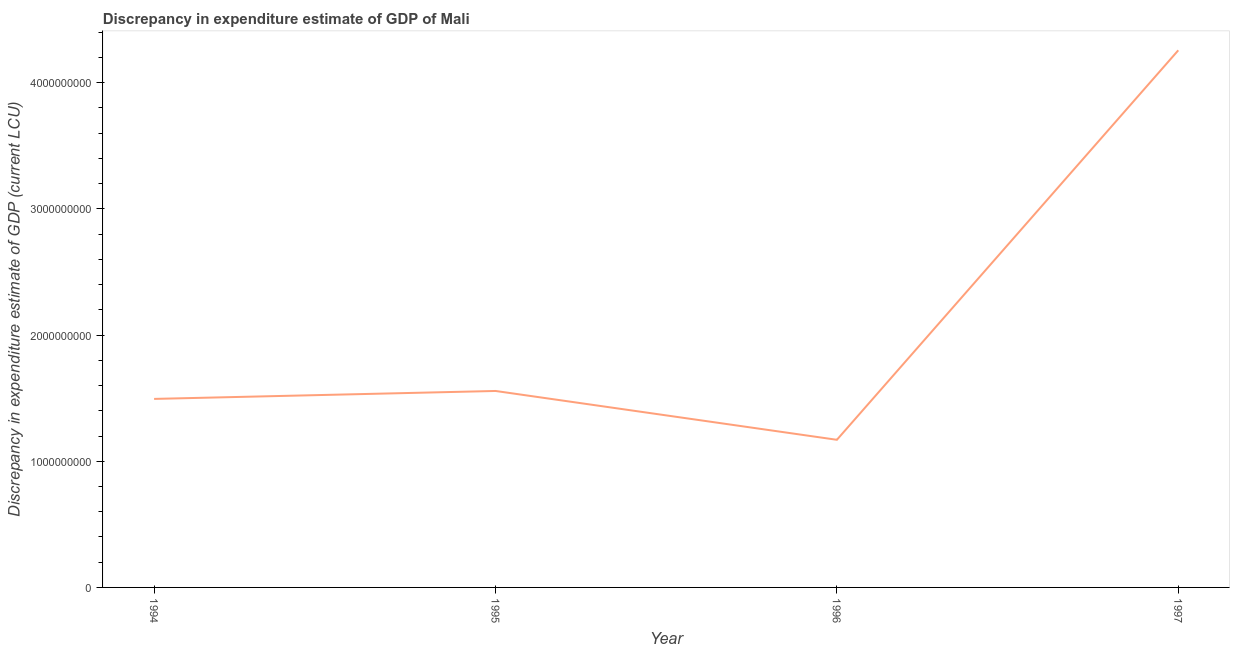What is the discrepancy in expenditure estimate of gdp in 1997?
Offer a very short reply. 4.26e+09. Across all years, what is the maximum discrepancy in expenditure estimate of gdp?
Give a very brief answer. 4.26e+09. Across all years, what is the minimum discrepancy in expenditure estimate of gdp?
Provide a short and direct response. 1.17e+09. What is the sum of the discrepancy in expenditure estimate of gdp?
Make the answer very short. 8.48e+09. What is the difference between the discrepancy in expenditure estimate of gdp in 1995 and 1996?
Offer a terse response. 3.87e+08. What is the average discrepancy in expenditure estimate of gdp per year?
Offer a very short reply. 2.12e+09. What is the median discrepancy in expenditure estimate of gdp?
Provide a short and direct response. 1.53e+09. In how many years, is the discrepancy in expenditure estimate of gdp greater than 2800000000 LCU?
Provide a succinct answer. 1. What is the ratio of the discrepancy in expenditure estimate of gdp in 1996 to that in 1997?
Your answer should be compact. 0.27. Is the difference between the discrepancy in expenditure estimate of gdp in 1994 and 1997 greater than the difference between any two years?
Provide a short and direct response. No. What is the difference between the highest and the second highest discrepancy in expenditure estimate of gdp?
Offer a terse response. 2.70e+09. What is the difference between the highest and the lowest discrepancy in expenditure estimate of gdp?
Your response must be concise. 3.09e+09. In how many years, is the discrepancy in expenditure estimate of gdp greater than the average discrepancy in expenditure estimate of gdp taken over all years?
Offer a terse response. 1. Does the discrepancy in expenditure estimate of gdp monotonically increase over the years?
Ensure brevity in your answer.  No. How many years are there in the graph?
Keep it short and to the point. 4. What is the title of the graph?
Your answer should be very brief. Discrepancy in expenditure estimate of GDP of Mali. What is the label or title of the X-axis?
Give a very brief answer. Year. What is the label or title of the Y-axis?
Give a very brief answer. Discrepancy in expenditure estimate of GDP (current LCU). What is the Discrepancy in expenditure estimate of GDP (current LCU) of 1994?
Provide a succinct answer. 1.49e+09. What is the Discrepancy in expenditure estimate of GDP (current LCU) in 1995?
Your answer should be very brief. 1.56e+09. What is the Discrepancy in expenditure estimate of GDP (current LCU) in 1996?
Offer a very short reply. 1.17e+09. What is the Discrepancy in expenditure estimate of GDP (current LCU) in 1997?
Your answer should be very brief. 4.26e+09. What is the difference between the Discrepancy in expenditure estimate of GDP (current LCU) in 1994 and 1995?
Make the answer very short. -6.30e+07. What is the difference between the Discrepancy in expenditure estimate of GDP (current LCU) in 1994 and 1996?
Offer a terse response. 3.24e+08. What is the difference between the Discrepancy in expenditure estimate of GDP (current LCU) in 1994 and 1997?
Your answer should be very brief. -2.76e+09. What is the difference between the Discrepancy in expenditure estimate of GDP (current LCU) in 1995 and 1996?
Your answer should be compact. 3.87e+08. What is the difference between the Discrepancy in expenditure estimate of GDP (current LCU) in 1995 and 1997?
Ensure brevity in your answer.  -2.70e+09. What is the difference between the Discrepancy in expenditure estimate of GDP (current LCU) in 1996 and 1997?
Provide a succinct answer. -3.09e+09. What is the ratio of the Discrepancy in expenditure estimate of GDP (current LCU) in 1994 to that in 1996?
Provide a short and direct response. 1.28. What is the ratio of the Discrepancy in expenditure estimate of GDP (current LCU) in 1994 to that in 1997?
Provide a succinct answer. 0.35. What is the ratio of the Discrepancy in expenditure estimate of GDP (current LCU) in 1995 to that in 1996?
Offer a very short reply. 1.33. What is the ratio of the Discrepancy in expenditure estimate of GDP (current LCU) in 1995 to that in 1997?
Offer a very short reply. 0.37. What is the ratio of the Discrepancy in expenditure estimate of GDP (current LCU) in 1996 to that in 1997?
Provide a short and direct response. 0.28. 